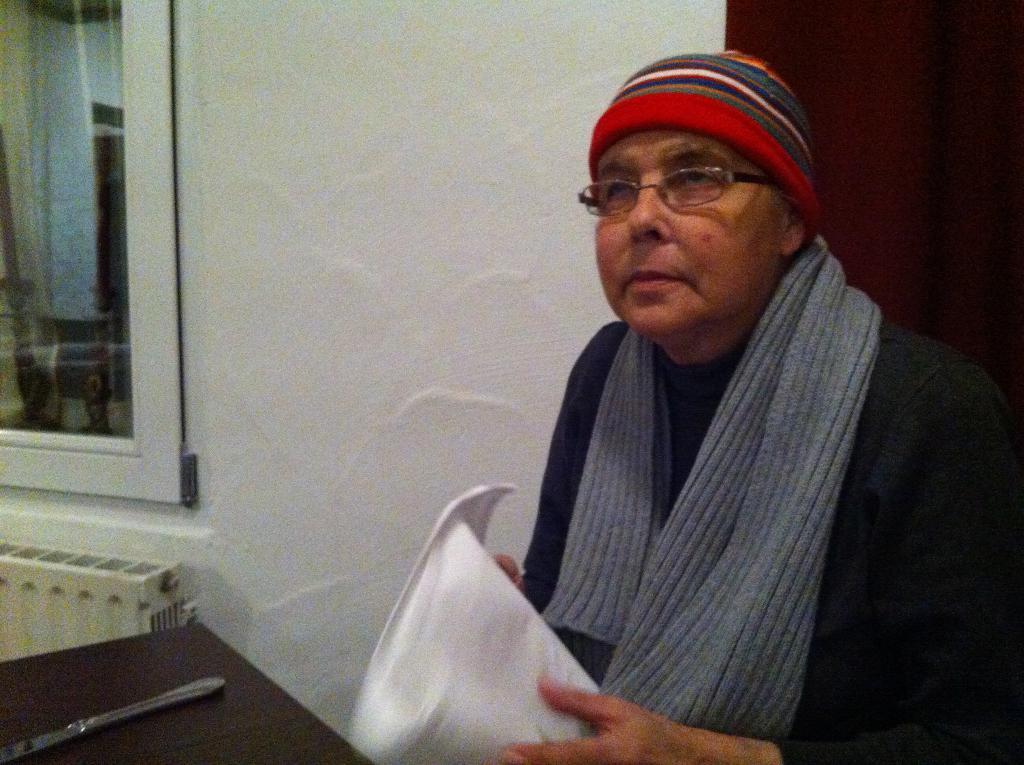In one or two sentences, can you explain what this image depicts? In this image we can see a person sitting and holding an object, in front of him we can see a table with a knife on it, in the background we can see the wall and a window. 